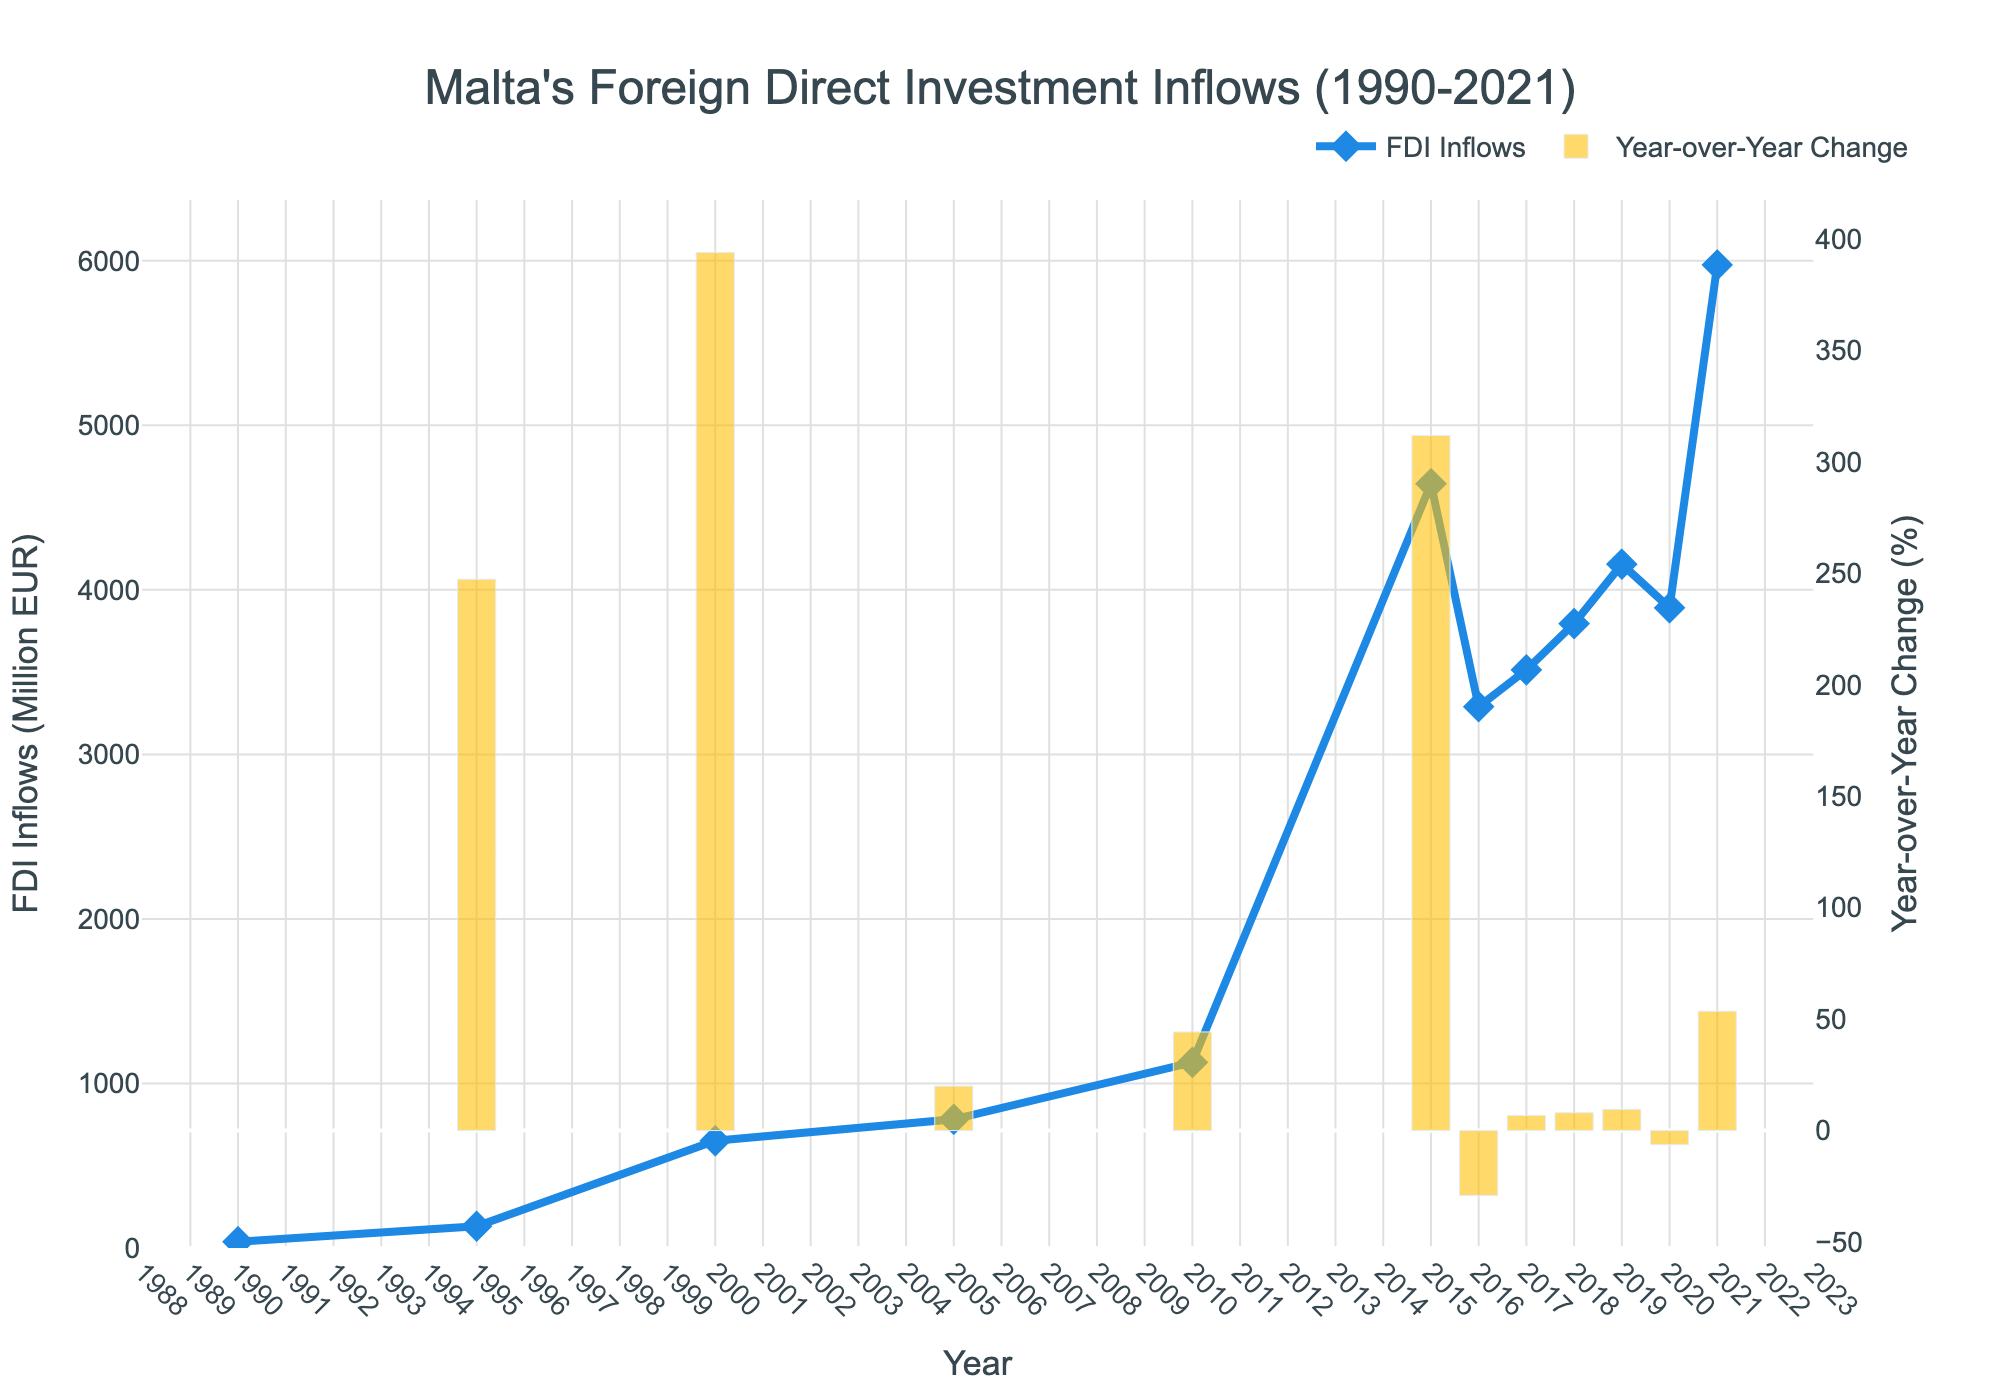What year had the highest FDI inflows? By visually examining the line plot, the highest point on the chart corresponds to the year 2021. The y-axis label for this year indicates the highest FDI inflows.
Answer: 2021 What is the percentage difference in FDI inflows between 2015 and 2020? Firstly, locate the FDI inflows for 2015 and 2020, which are 4645 million EUR and 3891 million EUR respectively. Calculate the percentage difference using the formula: \[ \text{Percentage Difference} = \frac{\text{Later Value} - \text{Earlier Value}}{\text{Earlier Value}} \times 100 \]. Plugging in the values, we have: \[ \text{Percentage Difference} = \frac{3891 - 4645}{4645} \times 100 = -16.24\%.
Answer: -16.24% How did the FDI inflows change between 2005 and 2010? By looking at the line plot, identify the data points for 2005 and 2010. The FDI inflows in 2005 were 782 million EUR and in 2010 were 1128 million EUR. Calculate the difference: 1128 - 782 = 346 million EUR. Therefore, the FDI inflows increased by 346 million EUR.
Answer: Increased by 346 million EUR Which year had the largest year-over-year change in FDI inflows? By examining the bar chart which represents year-over-year change, locate the tallest bar, which visually represents the largest year-over-year change. The tallest bar corresponds to the year 2021.
Answer: 2021 What were the FDI inflows in 2000, and how does it compare to 2021? According to the chart, in 2000, the FDI inflows were 652 million EUR, and in 2021, they were 5975 million EUR. Comparing these values, FDI inflows increased by 5323 million EUR from 2000 to 2021.
Answer: 5975 million EUR increased by 5323 million EUR Calculate the average FDI inflows for the decade 2010-2020. Identify the FDI inflows data points for the years 2010, 2015, 2016, 2017, 2018, 2019, and 2020: 1128, 4645, 3290, 3514, 3795, 4156, and 3891 million EUR respectively. Sum these values and divide by the number of years: \[ \text{Average} = \frac{1128+4645+3290+3514+3795+4156+3891}{7} = \frac{24419}{7} \approx 3488 \].
Answer: 3488 million EUR Which year experienced the most significant drop in FDI inflows, and what was the percentage decrease? Examine the bar chart to find the smallest (most negative) bar value, indicating the most significant drop. This occurs between 2015 and 2016. FDI inflows for these years were 4645 million EUR and 3290 million EUR respectively. Calculate the percentage decrease: \[ \frac{3290 - 4645}{4645} \times 100 = -29.15\% \].
Answer: 2016, -29.15% Compare the FDI inflows in 1995 and 2000. What is the difference, and by what factor has it changed? Identify the FDI inflows for 1995 and 2000: 132 million EUR and 652 million EUR respectively. Calculate the difference: 652 - 132 = 520 million EUR. Then, find the factor change: \[ \text{Factor Change} = \frac{652}{132} \approx 4.94 \].
Answer: Difference: 520 million EUR, Factor change: 4.94 How did the trend in FDI inflows change from 1990 to 2005? By observing the line plot from 1990 to 2005, we see a gradual increase in the FDI inflows starting from 38 million EUR in 1990 to 782 million EUR in 2005, indicating an upward trend.
Answer: Upward trend 